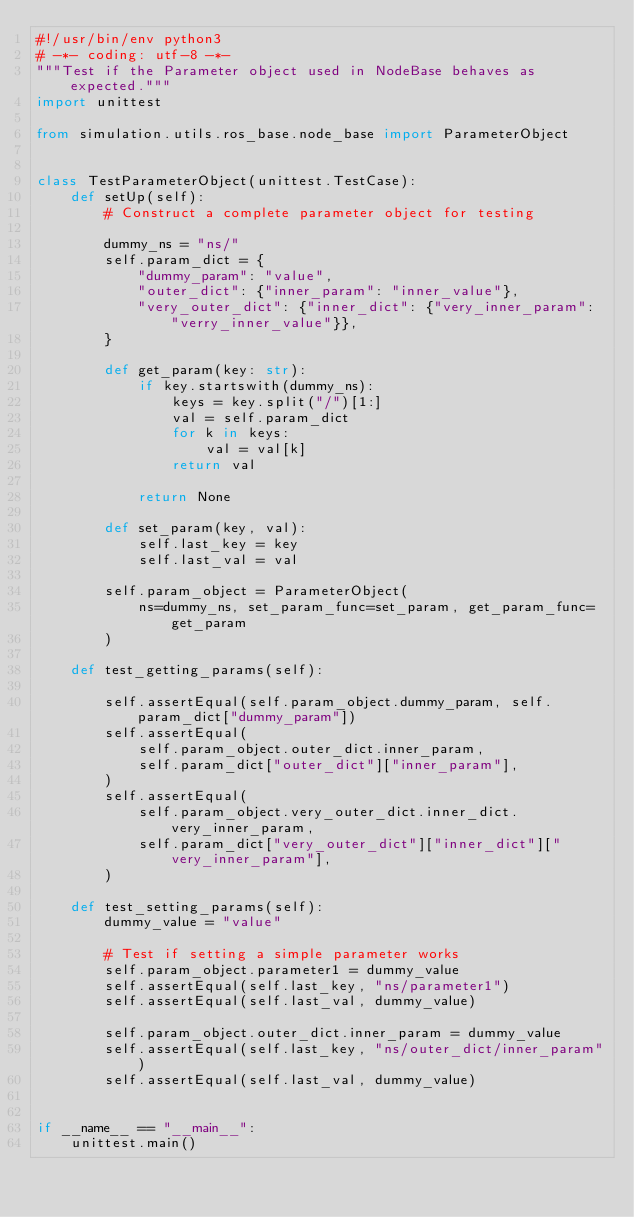<code> <loc_0><loc_0><loc_500><loc_500><_Python_>#!/usr/bin/env python3
# -*- coding: utf-8 -*-
"""Test if the Parameter object used in NodeBase behaves as expected."""
import unittest

from simulation.utils.ros_base.node_base import ParameterObject


class TestParameterObject(unittest.TestCase):
    def setUp(self):
        # Construct a complete parameter object for testing

        dummy_ns = "ns/"
        self.param_dict = {
            "dummy_param": "value",
            "outer_dict": {"inner_param": "inner_value"},
            "very_outer_dict": {"inner_dict": {"very_inner_param": "verry_inner_value"}},
        }

        def get_param(key: str):
            if key.startswith(dummy_ns):
                keys = key.split("/")[1:]
                val = self.param_dict
                for k in keys:
                    val = val[k]
                return val

            return None

        def set_param(key, val):
            self.last_key = key
            self.last_val = val

        self.param_object = ParameterObject(
            ns=dummy_ns, set_param_func=set_param, get_param_func=get_param
        )

    def test_getting_params(self):

        self.assertEqual(self.param_object.dummy_param, self.param_dict["dummy_param"])
        self.assertEqual(
            self.param_object.outer_dict.inner_param,
            self.param_dict["outer_dict"]["inner_param"],
        )
        self.assertEqual(
            self.param_object.very_outer_dict.inner_dict.very_inner_param,
            self.param_dict["very_outer_dict"]["inner_dict"]["very_inner_param"],
        )

    def test_setting_params(self):
        dummy_value = "value"

        # Test if setting a simple parameter works
        self.param_object.parameter1 = dummy_value
        self.assertEqual(self.last_key, "ns/parameter1")
        self.assertEqual(self.last_val, dummy_value)

        self.param_object.outer_dict.inner_param = dummy_value
        self.assertEqual(self.last_key, "ns/outer_dict/inner_param")
        self.assertEqual(self.last_val, dummy_value)


if __name__ == "__main__":
    unittest.main()
</code> 